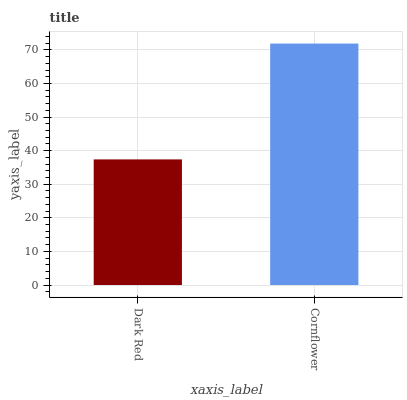Is Dark Red the minimum?
Answer yes or no. Yes. Is Cornflower the maximum?
Answer yes or no. Yes. Is Cornflower the minimum?
Answer yes or no. No. Is Cornflower greater than Dark Red?
Answer yes or no. Yes. Is Dark Red less than Cornflower?
Answer yes or no. Yes. Is Dark Red greater than Cornflower?
Answer yes or no. No. Is Cornflower less than Dark Red?
Answer yes or no. No. Is Cornflower the high median?
Answer yes or no. Yes. Is Dark Red the low median?
Answer yes or no. Yes. Is Dark Red the high median?
Answer yes or no. No. Is Cornflower the low median?
Answer yes or no. No. 